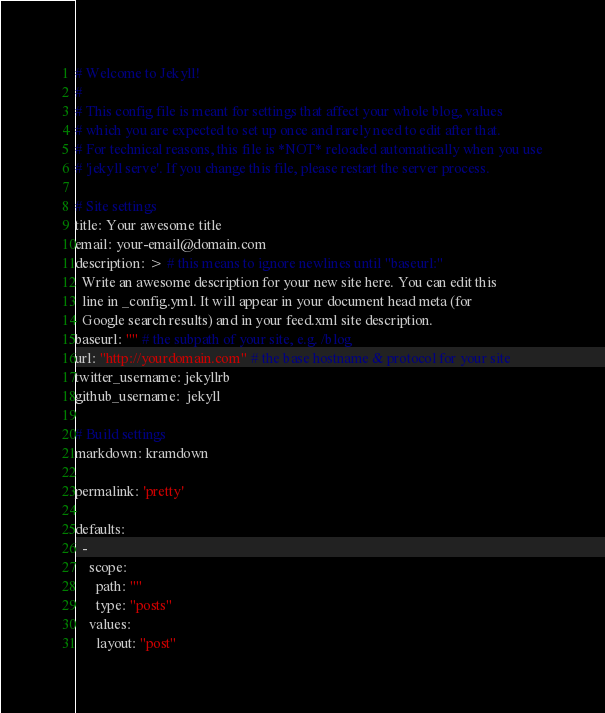<code> <loc_0><loc_0><loc_500><loc_500><_YAML_># Welcome to Jekyll!
#
# This config file is meant for settings that affect your whole blog, values
# which you are expected to set up once and rarely need to edit after that.
# For technical reasons, this file is *NOT* reloaded automatically when you use
# 'jekyll serve'. If you change this file, please restart the server process.

# Site settings
title: Your awesome title
email: your-email@domain.com
description: > # this means to ignore newlines until "baseurl:"
  Write an awesome description for your new site here. You can edit this
  line in _config.yml. It will appear in your document head meta (for
  Google search results) and in your feed.xml site description.
baseurl: "" # the subpath of your site, e.g. /blog
url: "http://yourdomain.com" # the base hostname & protocol for your site
twitter_username: jekyllrb
github_username:  jekyll

# Build settings
markdown: kramdown

permalink: 'pretty'

defaults:
  -
    scope:
      path: ""
      type: "posts"
    values:
      layout: "post"
</code> 